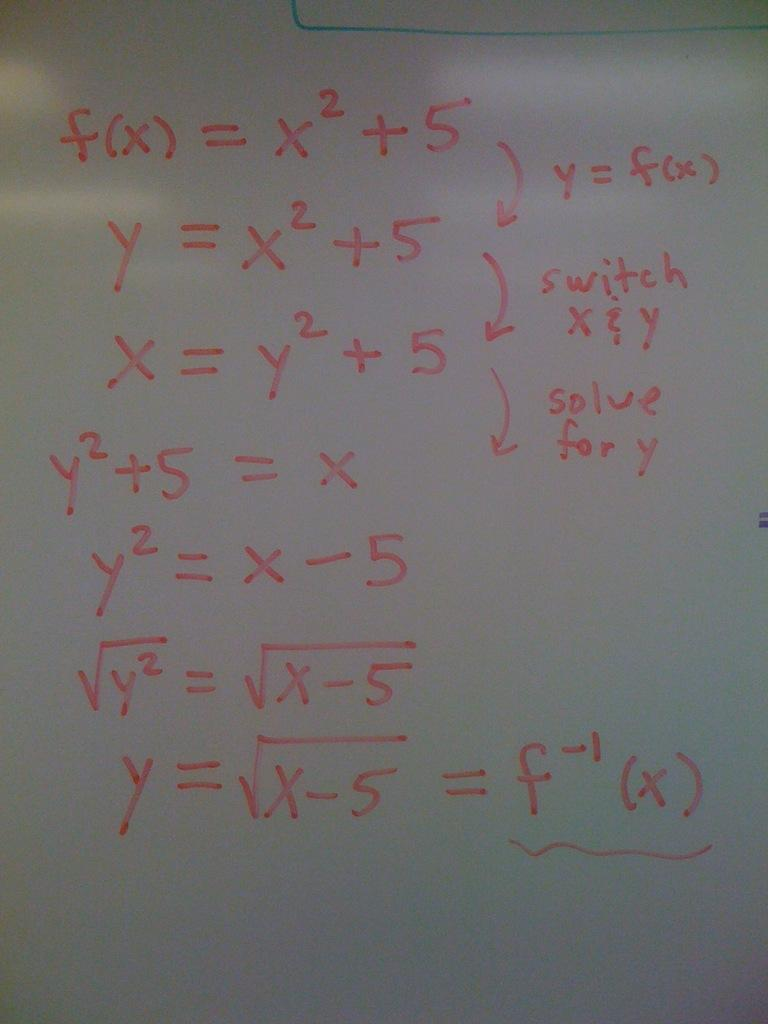Provide a one-sentence caption for the provided image. White board which shows equations in cluding one which has the answer of fx. 